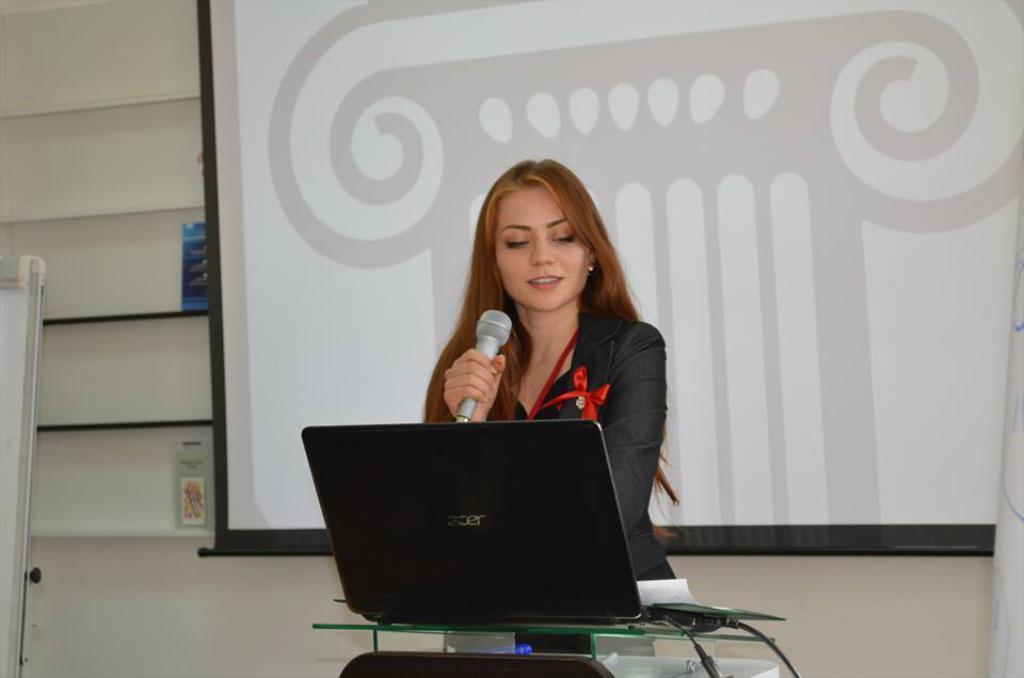Please provide a concise description of this image. There is a lady holding a mic in the foreground area of the image, there is a laptop on a desk in front of her. There is a board, other objects and projector screen in the background. 